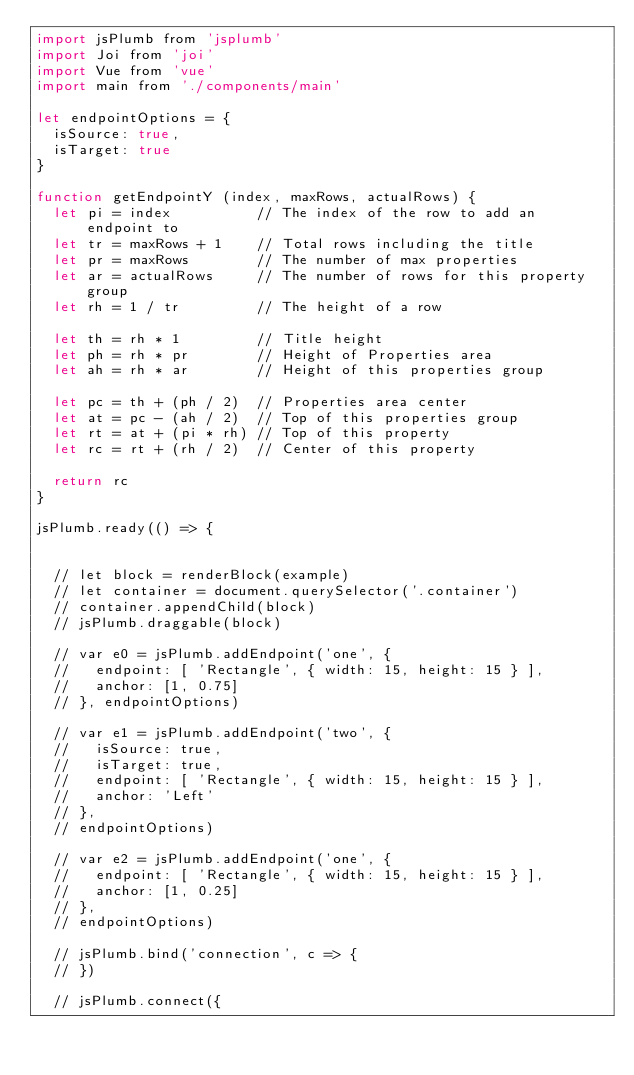<code> <loc_0><loc_0><loc_500><loc_500><_JavaScript_>import jsPlumb from 'jsplumb'
import Joi from 'joi'
import Vue from 'vue'
import main from './components/main'

let endpointOptions = {
  isSource: true,
  isTarget: true
}

function getEndpointY (index, maxRows, actualRows) {
  let pi = index          // The index of the row to add an endpoint to
  let tr = maxRows + 1    // Total rows including the title
  let pr = maxRows        // The number of max properties
  let ar = actualRows     // The number of rows for this property group
  let rh = 1 / tr         // The height of a row

  let th = rh * 1         // Title height
  let ph = rh * pr        // Height of Properties area
  let ah = rh * ar        // Height of this properties group

  let pc = th + (ph / 2)  // Properties area center
  let at = pc - (ah / 2)  // Top of this properties group
  let rt = at + (pi * rh) // Top of this property
  let rc = rt + (rh / 2)  // Center of this property

  return rc
}

jsPlumb.ready(() => {


  // let block = renderBlock(example)
  // let container = document.querySelector('.container')
  // container.appendChild(block)
  // jsPlumb.draggable(block)

  // var e0 = jsPlumb.addEndpoint('one', {
  //   endpoint: [ 'Rectangle', { width: 15, height: 15 } ],
  //   anchor: [1, 0.75]
  // }, endpointOptions)

  // var e1 = jsPlumb.addEndpoint('two', {
  //   isSource: true,
  //   isTarget: true,
  //   endpoint: [ 'Rectangle', { width: 15, height: 15 } ],
  //   anchor: 'Left'
  // },
  // endpointOptions)

  // var e2 = jsPlumb.addEndpoint('one', {
  //   endpoint: [ 'Rectangle', { width: 15, height: 15 } ],
  //   anchor: [1, 0.25]
  // },
  // endpointOptions)

  // jsPlumb.bind('connection', c => {
  // })

  // jsPlumb.connect({</code> 